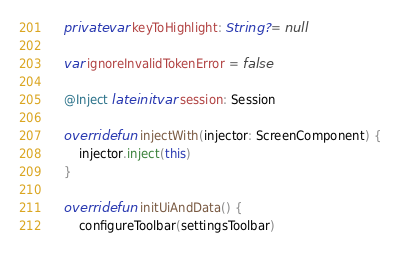<code> <loc_0><loc_0><loc_500><loc_500><_Kotlin_>
    private var keyToHighlight: String? = null

    var ignoreInvalidTokenError = false

    @Inject lateinit var session: Session

    override fun injectWith(injector: ScreenComponent) {
        injector.inject(this)
    }

    override fun initUiAndData() {
        configureToolbar(settingsToolbar)
</code> 